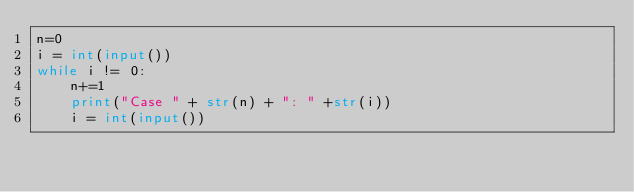<code> <loc_0><loc_0><loc_500><loc_500><_Python_>n=0
i = int(input())
while i != 0:
    n+=1
    print("Case " + str(n) + ": " +str(i))
    i = int(input())
</code> 